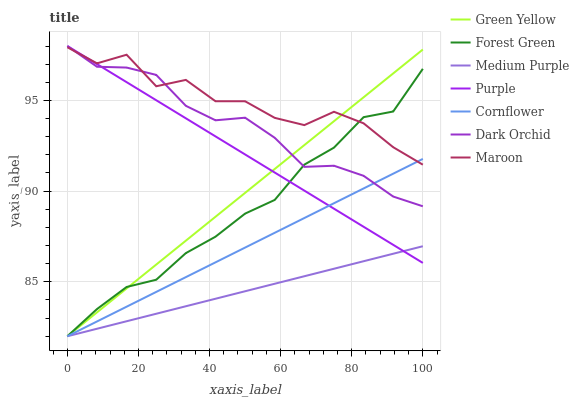Does Medium Purple have the minimum area under the curve?
Answer yes or no. Yes. Does Maroon have the maximum area under the curve?
Answer yes or no. Yes. Does Purple have the minimum area under the curve?
Answer yes or no. No. Does Purple have the maximum area under the curve?
Answer yes or no. No. Is Green Yellow the smoothest?
Answer yes or no. Yes. Is Maroon the roughest?
Answer yes or no. Yes. Is Purple the smoothest?
Answer yes or no. No. Is Purple the roughest?
Answer yes or no. No. Does Cornflower have the lowest value?
Answer yes or no. Yes. Does Purple have the lowest value?
Answer yes or no. No. Does Dark Orchid have the highest value?
Answer yes or no. Yes. Does Medium Purple have the highest value?
Answer yes or no. No. Is Medium Purple less than Maroon?
Answer yes or no. Yes. Is Dark Orchid greater than Medium Purple?
Answer yes or no. Yes. Does Medium Purple intersect Forest Green?
Answer yes or no. Yes. Is Medium Purple less than Forest Green?
Answer yes or no. No. Is Medium Purple greater than Forest Green?
Answer yes or no. No. Does Medium Purple intersect Maroon?
Answer yes or no. No. 